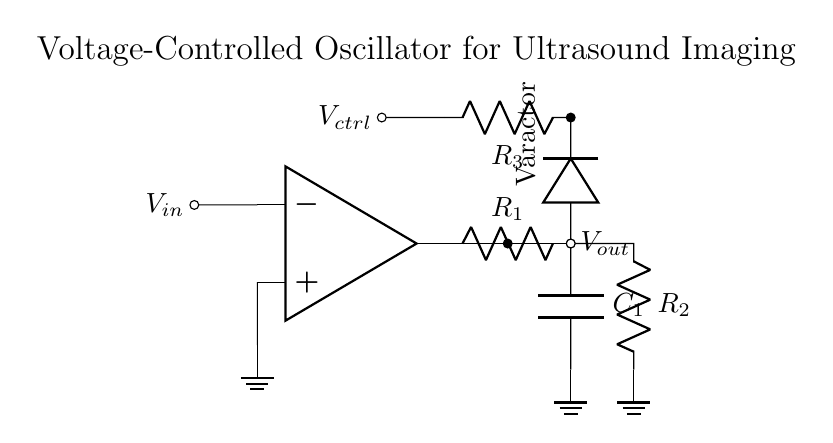What is the main component used for frequency adjustment in this circuit? The main component for frequency adjustment is the varactor diode, which varies its capacitance based on the control voltage applied.
Answer: Varactor diode What does the term \( V_{ctrl} \) represent in this circuit? \( V_{ctrl} \) represents the control voltage that influences the capacitance of the varactor diode, thereby adjusting the frequency of the output signal.
Answer: Control voltage How many resistors are present in the circuit? There are three resistors labeled \( R_1, R_2, \) and \( R_3 \) that provide resistive elements in the feedback and control loops.
Answer: Three What is the role of the op-amp in this circuit? The op-amp is used as an oscillator to amplify the signals, enabling oscillation at the desired frequency determined by the feedback components.
Answer: Amplification What happens to the frequency output \( V_{out} \) when \( V_{ctrl} \) increases? When \( V_{ctrl} \) increases, the capacitance of the varactor diode decreases, leading to a higher frequency output in this voltage-controlled oscillator configuration.
Answer: Increases What type of circuit is this specifically classified as? This circuit is a voltage-controlled oscillator, specifically designed to generate waveforms at frequencies adjustable through an input voltage.
Answer: Voltage-controlled oscillator 